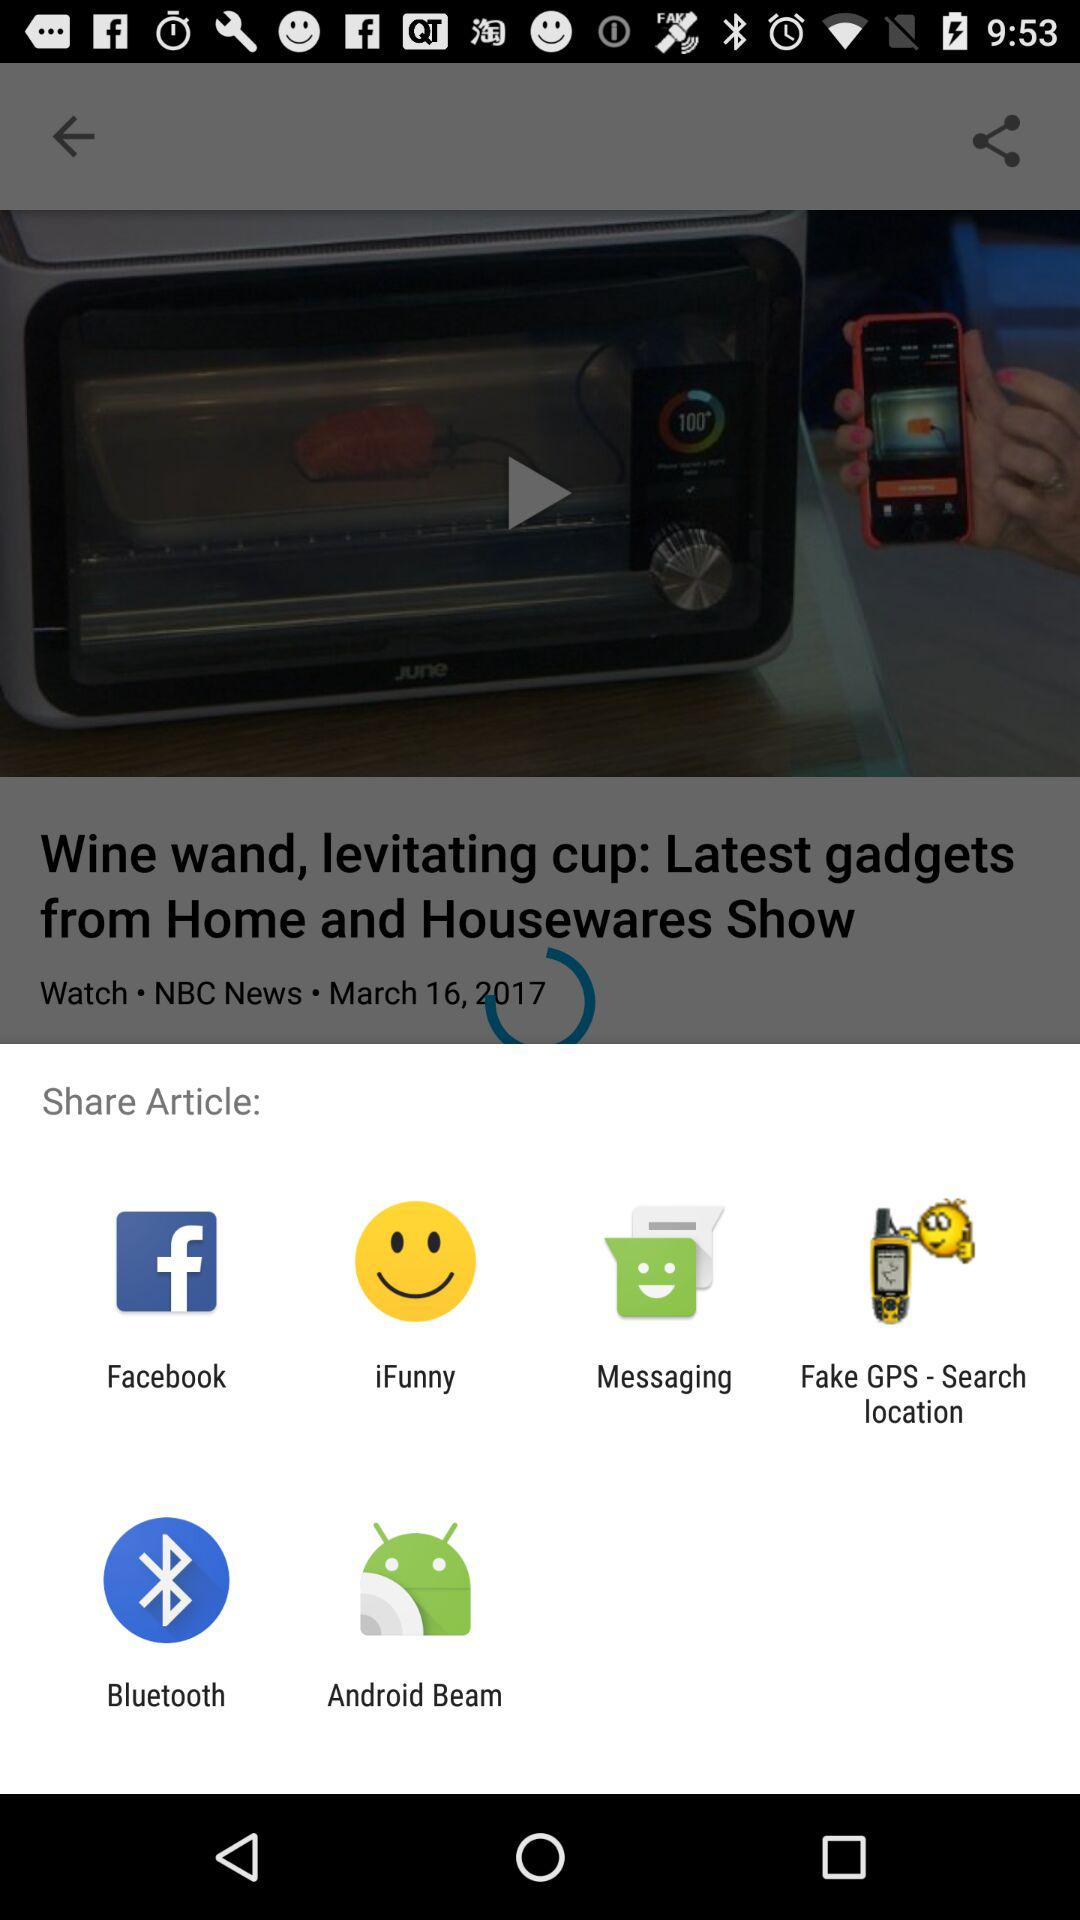By which app can we share the article? You can share the article with "Facebook", "iFunny", "Messaging", "Fake GPS - Search location", "Bluetooth" and "Android Beam". 